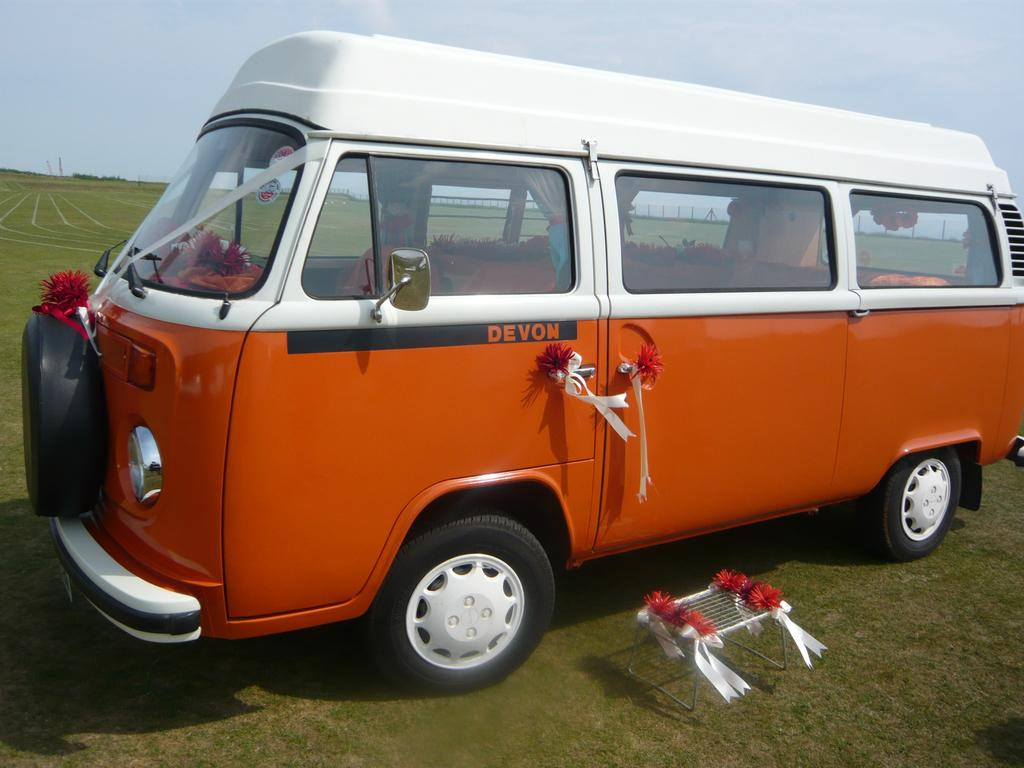<image>
Provide a brief description of the given image. a van that says devon on the side 